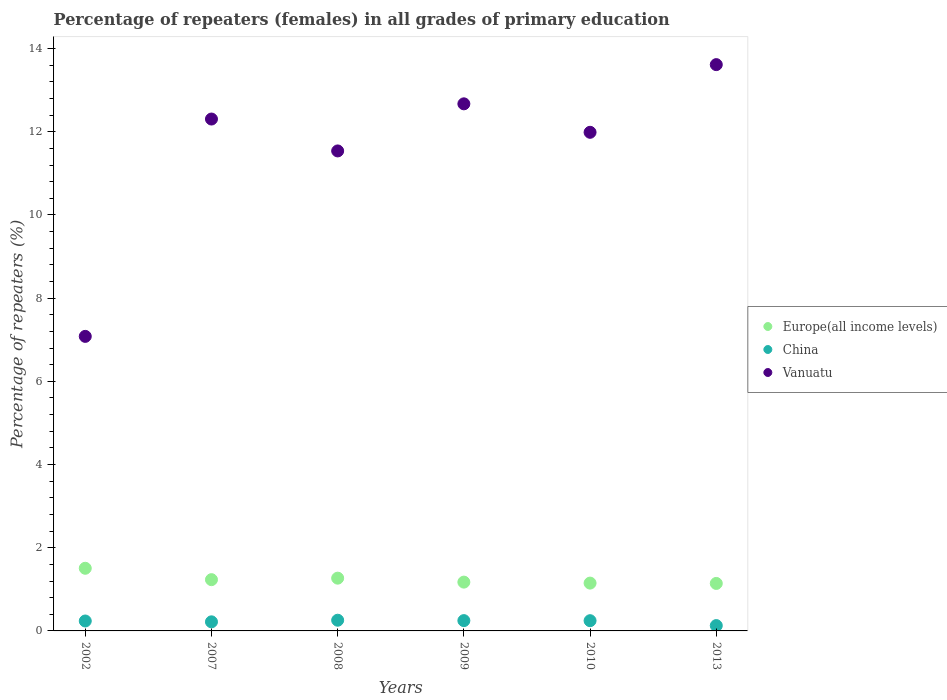How many different coloured dotlines are there?
Your response must be concise. 3. Is the number of dotlines equal to the number of legend labels?
Offer a terse response. Yes. What is the percentage of repeaters (females) in Europe(all income levels) in 2002?
Offer a very short reply. 1.51. Across all years, what is the maximum percentage of repeaters (females) in Vanuatu?
Offer a terse response. 13.61. Across all years, what is the minimum percentage of repeaters (females) in China?
Provide a succinct answer. 0.13. What is the total percentage of repeaters (females) in Europe(all income levels) in the graph?
Your response must be concise. 7.47. What is the difference between the percentage of repeaters (females) in China in 2002 and that in 2007?
Give a very brief answer. 0.02. What is the difference between the percentage of repeaters (females) in Vanuatu in 2009 and the percentage of repeaters (females) in China in 2010?
Offer a terse response. 12.42. What is the average percentage of repeaters (females) in Vanuatu per year?
Provide a succinct answer. 11.53. In the year 2009, what is the difference between the percentage of repeaters (females) in Europe(all income levels) and percentage of repeaters (females) in Vanuatu?
Your answer should be compact. -11.5. In how many years, is the percentage of repeaters (females) in Vanuatu greater than 10.4 %?
Provide a short and direct response. 5. What is the ratio of the percentage of repeaters (females) in China in 2002 to that in 2009?
Offer a terse response. 0.96. Is the difference between the percentage of repeaters (females) in Europe(all income levels) in 2008 and 2009 greater than the difference between the percentage of repeaters (females) in Vanuatu in 2008 and 2009?
Keep it short and to the point. Yes. What is the difference between the highest and the second highest percentage of repeaters (females) in Vanuatu?
Offer a very short reply. 0.94. What is the difference between the highest and the lowest percentage of repeaters (females) in Vanuatu?
Keep it short and to the point. 6.53. In how many years, is the percentage of repeaters (females) in Europe(all income levels) greater than the average percentage of repeaters (females) in Europe(all income levels) taken over all years?
Provide a short and direct response. 2. Is the percentage of repeaters (females) in China strictly greater than the percentage of repeaters (females) in Europe(all income levels) over the years?
Offer a terse response. No. What is the difference between two consecutive major ticks on the Y-axis?
Your response must be concise. 2. Are the values on the major ticks of Y-axis written in scientific E-notation?
Keep it short and to the point. No. Does the graph contain any zero values?
Your answer should be very brief. No. Does the graph contain grids?
Give a very brief answer. No. Where does the legend appear in the graph?
Provide a short and direct response. Center right. What is the title of the graph?
Your answer should be compact. Percentage of repeaters (females) in all grades of primary education. Does "Cyprus" appear as one of the legend labels in the graph?
Your response must be concise. No. What is the label or title of the X-axis?
Ensure brevity in your answer.  Years. What is the label or title of the Y-axis?
Your answer should be very brief. Percentage of repeaters (%). What is the Percentage of repeaters (%) in Europe(all income levels) in 2002?
Offer a very short reply. 1.51. What is the Percentage of repeaters (%) in China in 2002?
Your answer should be very brief. 0.24. What is the Percentage of repeaters (%) in Vanuatu in 2002?
Your answer should be compact. 7.08. What is the Percentage of repeaters (%) in Europe(all income levels) in 2007?
Your response must be concise. 1.23. What is the Percentage of repeaters (%) in China in 2007?
Provide a succinct answer. 0.22. What is the Percentage of repeaters (%) of Vanuatu in 2007?
Keep it short and to the point. 12.31. What is the Percentage of repeaters (%) in Europe(all income levels) in 2008?
Offer a very short reply. 1.27. What is the Percentage of repeaters (%) in China in 2008?
Offer a very short reply. 0.26. What is the Percentage of repeaters (%) in Vanuatu in 2008?
Give a very brief answer. 11.54. What is the Percentage of repeaters (%) of Europe(all income levels) in 2009?
Keep it short and to the point. 1.17. What is the Percentage of repeaters (%) in China in 2009?
Your answer should be very brief. 0.25. What is the Percentage of repeaters (%) in Vanuatu in 2009?
Your answer should be compact. 12.67. What is the Percentage of repeaters (%) of Europe(all income levels) in 2010?
Your answer should be compact. 1.15. What is the Percentage of repeaters (%) of China in 2010?
Ensure brevity in your answer.  0.25. What is the Percentage of repeaters (%) of Vanuatu in 2010?
Your answer should be very brief. 11.99. What is the Percentage of repeaters (%) of Europe(all income levels) in 2013?
Offer a terse response. 1.14. What is the Percentage of repeaters (%) of China in 2013?
Your answer should be compact. 0.13. What is the Percentage of repeaters (%) in Vanuatu in 2013?
Give a very brief answer. 13.61. Across all years, what is the maximum Percentage of repeaters (%) of Europe(all income levels)?
Make the answer very short. 1.51. Across all years, what is the maximum Percentage of repeaters (%) in China?
Provide a short and direct response. 0.26. Across all years, what is the maximum Percentage of repeaters (%) in Vanuatu?
Your answer should be compact. 13.61. Across all years, what is the minimum Percentage of repeaters (%) of Europe(all income levels)?
Make the answer very short. 1.14. Across all years, what is the minimum Percentage of repeaters (%) in China?
Provide a short and direct response. 0.13. Across all years, what is the minimum Percentage of repeaters (%) in Vanuatu?
Offer a terse response. 7.08. What is the total Percentage of repeaters (%) in Europe(all income levels) in the graph?
Your answer should be compact. 7.47. What is the total Percentage of repeaters (%) in China in the graph?
Make the answer very short. 1.34. What is the total Percentage of repeaters (%) of Vanuatu in the graph?
Your answer should be compact. 69.19. What is the difference between the Percentage of repeaters (%) of Europe(all income levels) in 2002 and that in 2007?
Offer a terse response. 0.27. What is the difference between the Percentage of repeaters (%) in Vanuatu in 2002 and that in 2007?
Provide a succinct answer. -5.22. What is the difference between the Percentage of repeaters (%) of Europe(all income levels) in 2002 and that in 2008?
Your answer should be very brief. 0.24. What is the difference between the Percentage of repeaters (%) of China in 2002 and that in 2008?
Your response must be concise. -0.02. What is the difference between the Percentage of repeaters (%) in Vanuatu in 2002 and that in 2008?
Ensure brevity in your answer.  -4.46. What is the difference between the Percentage of repeaters (%) in Europe(all income levels) in 2002 and that in 2009?
Provide a short and direct response. 0.33. What is the difference between the Percentage of repeaters (%) in China in 2002 and that in 2009?
Offer a terse response. -0.01. What is the difference between the Percentage of repeaters (%) in Vanuatu in 2002 and that in 2009?
Ensure brevity in your answer.  -5.59. What is the difference between the Percentage of repeaters (%) of Europe(all income levels) in 2002 and that in 2010?
Offer a very short reply. 0.36. What is the difference between the Percentage of repeaters (%) in China in 2002 and that in 2010?
Your answer should be compact. -0.01. What is the difference between the Percentage of repeaters (%) of Vanuatu in 2002 and that in 2010?
Make the answer very short. -4.91. What is the difference between the Percentage of repeaters (%) of Europe(all income levels) in 2002 and that in 2013?
Keep it short and to the point. 0.36. What is the difference between the Percentage of repeaters (%) in China in 2002 and that in 2013?
Ensure brevity in your answer.  0.11. What is the difference between the Percentage of repeaters (%) in Vanuatu in 2002 and that in 2013?
Give a very brief answer. -6.53. What is the difference between the Percentage of repeaters (%) in Europe(all income levels) in 2007 and that in 2008?
Ensure brevity in your answer.  -0.04. What is the difference between the Percentage of repeaters (%) in China in 2007 and that in 2008?
Your response must be concise. -0.04. What is the difference between the Percentage of repeaters (%) of Vanuatu in 2007 and that in 2008?
Provide a short and direct response. 0.77. What is the difference between the Percentage of repeaters (%) in Europe(all income levels) in 2007 and that in 2009?
Give a very brief answer. 0.06. What is the difference between the Percentage of repeaters (%) of China in 2007 and that in 2009?
Ensure brevity in your answer.  -0.03. What is the difference between the Percentage of repeaters (%) in Vanuatu in 2007 and that in 2009?
Offer a very short reply. -0.37. What is the difference between the Percentage of repeaters (%) of Europe(all income levels) in 2007 and that in 2010?
Your answer should be very brief. 0.08. What is the difference between the Percentage of repeaters (%) in China in 2007 and that in 2010?
Keep it short and to the point. -0.03. What is the difference between the Percentage of repeaters (%) in Vanuatu in 2007 and that in 2010?
Ensure brevity in your answer.  0.32. What is the difference between the Percentage of repeaters (%) of Europe(all income levels) in 2007 and that in 2013?
Your answer should be compact. 0.09. What is the difference between the Percentage of repeaters (%) of China in 2007 and that in 2013?
Keep it short and to the point. 0.09. What is the difference between the Percentage of repeaters (%) of Vanuatu in 2007 and that in 2013?
Offer a terse response. -1.31. What is the difference between the Percentage of repeaters (%) of Europe(all income levels) in 2008 and that in 2009?
Your answer should be compact. 0.1. What is the difference between the Percentage of repeaters (%) in China in 2008 and that in 2009?
Ensure brevity in your answer.  0.01. What is the difference between the Percentage of repeaters (%) of Vanuatu in 2008 and that in 2009?
Make the answer very short. -1.13. What is the difference between the Percentage of repeaters (%) of Europe(all income levels) in 2008 and that in 2010?
Keep it short and to the point. 0.12. What is the difference between the Percentage of repeaters (%) of China in 2008 and that in 2010?
Ensure brevity in your answer.  0.01. What is the difference between the Percentage of repeaters (%) in Vanuatu in 2008 and that in 2010?
Provide a short and direct response. -0.45. What is the difference between the Percentage of repeaters (%) of Europe(all income levels) in 2008 and that in 2013?
Give a very brief answer. 0.13. What is the difference between the Percentage of repeaters (%) in China in 2008 and that in 2013?
Ensure brevity in your answer.  0.13. What is the difference between the Percentage of repeaters (%) of Vanuatu in 2008 and that in 2013?
Keep it short and to the point. -2.07. What is the difference between the Percentage of repeaters (%) of Europe(all income levels) in 2009 and that in 2010?
Provide a succinct answer. 0.02. What is the difference between the Percentage of repeaters (%) of China in 2009 and that in 2010?
Give a very brief answer. 0. What is the difference between the Percentage of repeaters (%) in Vanuatu in 2009 and that in 2010?
Your answer should be compact. 0.68. What is the difference between the Percentage of repeaters (%) in Europe(all income levels) in 2009 and that in 2013?
Offer a terse response. 0.03. What is the difference between the Percentage of repeaters (%) of China in 2009 and that in 2013?
Offer a very short reply. 0.12. What is the difference between the Percentage of repeaters (%) in Vanuatu in 2009 and that in 2013?
Provide a short and direct response. -0.94. What is the difference between the Percentage of repeaters (%) of Europe(all income levels) in 2010 and that in 2013?
Provide a succinct answer. 0.01. What is the difference between the Percentage of repeaters (%) in China in 2010 and that in 2013?
Give a very brief answer. 0.12. What is the difference between the Percentage of repeaters (%) of Vanuatu in 2010 and that in 2013?
Give a very brief answer. -1.63. What is the difference between the Percentage of repeaters (%) of Europe(all income levels) in 2002 and the Percentage of repeaters (%) of China in 2007?
Your answer should be compact. 1.29. What is the difference between the Percentage of repeaters (%) in Europe(all income levels) in 2002 and the Percentage of repeaters (%) in Vanuatu in 2007?
Provide a succinct answer. -10.8. What is the difference between the Percentage of repeaters (%) of China in 2002 and the Percentage of repeaters (%) of Vanuatu in 2007?
Ensure brevity in your answer.  -12.07. What is the difference between the Percentage of repeaters (%) in Europe(all income levels) in 2002 and the Percentage of repeaters (%) in China in 2008?
Your response must be concise. 1.25. What is the difference between the Percentage of repeaters (%) in Europe(all income levels) in 2002 and the Percentage of repeaters (%) in Vanuatu in 2008?
Offer a very short reply. -10.03. What is the difference between the Percentage of repeaters (%) of China in 2002 and the Percentage of repeaters (%) of Vanuatu in 2008?
Offer a very short reply. -11.3. What is the difference between the Percentage of repeaters (%) of Europe(all income levels) in 2002 and the Percentage of repeaters (%) of China in 2009?
Offer a very short reply. 1.26. What is the difference between the Percentage of repeaters (%) of Europe(all income levels) in 2002 and the Percentage of repeaters (%) of Vanuatu in 2009?
Offer a terse response. -11.16. What is the difference between the Percentage of repeaters (%) of China in 2002 and the Percentage of repeaters (%) of Vanuatu in 2009?
Your answer should be compact. -12.43. What is the difference between the Percentage of repeaters (%) in Europe(all income levels) in 2002 and the Percentage of repeaters (%) in China in 2010?
Offer a very short reply. 1.26. What is the difference between the Percentage of repeaters (%) of Europe(all income levels) in 2002 and the Percentage of repeaters (%) of Vanuatu in 2010?
Give a very brief answer. -10.48. What is the difference between the Percentage of repeaters (%) in China in 2002 and the Percentage of repeaters (%) in Vanuatu in 2010?
Your response must be concise. -11.75. What is the difference between the Percentage of repeaters (%) in Europe(all income levels) in 2002 and the Percentage of repeaters (%) in China in 2013?
Ensure brevity in your answer.  1.38. What is the difference between the Percentage of repeaters (%) in Europe(all income levels) in 2002 and the Percentage of repeaters (%) in Vanuatu in 2013?
Give a very brief answer. -12.11. What is the difference between the Percentage of repeaters (%) in China in 2002 and the Percentage of repeaters (%) in Vanuatu in 2013?
Your answer should be very brief. -13.37. What is the difference between the Percentage of repeaters (%) in Europe(all income levels) in 2007 and the Percentage of repeaters (%) in China in 2008?
Your answer should be very brief. 0.98. What is the difference between the Percentage of repeaters (%) of Europe(all income levels) in 2007 and the Percentage of repeaters (%) of Vanuatu in 2008?
Make the answer very short. -10.31. What is the difference between the Percentage of repeaters (%) of China in 2007 and the Percentage of repeaters (%) of Vanuatu in 2008?
Make the answer very short. -11.32. What is the difference between the Percentage of repeaters (%) of Europe(all income levels) in 2007 and the Percentage of repeaters (%) of China in 2009?
Offer a very short reply. 0.98. What is the difference between the Percentage of repeaters (%) of Europe(all income levels) in 2007 and the Percentage of repeaters (%) of Vanuatu in 2009?
Ensure brevity in your answer.  -11.44. What is the difference between the Percentage of repeaters (%) of China in 2007 and the Percentage of repeaters (%) of Vanuatu in 2009?
Your answer should be very brief. -12.45. What is the difference between the Percentage of repeaters (%) of Europe(all income levels) in 2007 and the Percentage of repeaters (%) of China in 2010?
Your answer should be very brief. 0.99. What is the difference between the Percentage of repeaters (%) in Europe(all income levels) in 2007 and the Percentage of repeaters (%) in Vanuatu in 2010?
Provide a succinct answer. -10.75. What is the difference between the Percentage of repeaters (%) in China in 2007 and the Percentage of repeaters (%) in Vanuatu in 2010?
Your answer should be very brief. -11.77. What is the difference between the Percentage of repeaters (%) in Europe(all income levels) in 2007 and the Percentage of repeaters (%) in China in 2013?
Provide a short and direct response. 1.1. What is the difference between the Percentage of repeaters (%) of Europe(all income levels) in 2007 and the Percentage of repeaters (%) of Vanuatu in 2013?
Your answer should be compact. -12.38. What is the difference between the Percentage of repeaters (%) in China in 2007 and the Percentage of repeaters (%) in Vanuatu in 2013?
Give a very brief answer. -13.39. What is the difference between the Percentage of repeaters (%) in Europe(all income levels) in 2008 and the Percentage of repeaters (%) in China in 2009?
Ensure brevity in your answer.  1.02. What is the difference between the Percentage of repeaters (%) in Europe(all income levels) in 2008 and the Percentage of repeaters (%) in Vanuatu in 2009?
Offer a very short reply. -11.4. What is the difference between the Percentage of repeaters (%) of China in 2008 and the Percentage of repeaters (%) of Vanuatu in 2009?
Your answer should be very brief. -12.41. What is the difference between the Percentage of repeaters (%) in Europe(all income levels) in 2008 and the Percentage of repeaters (%) in China in 2010?
Provide a short and direct response. 1.02. What is the difference between the Percentage of repeaters (%) of Europe(all income levels) in 2008 and the Percentage of repeaters (%) of Vanuatu in 2010?
Your answer should be very brief. -10.72. What is the difference between the Percentage of repeaters (%) in China in 2008 and the Percentage of repeaters (%) in Vanuatu in 2010?
Give a very brief answer. -11.73. What is the difference between the Percentage of repeaters (%) in Europe(all income levels) in 2008 and the Percentage of repeaters (%) in China in 2013?
Give a very brief answer. 1.14. What is the difference between the Percentage of repeaters (%) of Europe(all income levels) in 2008 and the Percentage of repeaters (%) of Vanuatu in 2013?
Make the answer very short. -12.34. What is the difference between the Percentage of repeaters (%) of China in 2008 and the Percentage of repeaters (%) of Vanuatu in 2013?
Give a very brief answer. -13.36. What is the difference between the Percentage of repeaters (%) of Europe(all income levels) in 2009 and the Percentage of repeaters (%) of China in 2010?
Offer a terse response. 0.93. What is the difference between the Percentage of repeaters (%) in Europe(all income levels) in 2009 and the Percentage of repeaters (%) in Vanuatu in 2010?
Give a very brief answer. -10.81. What is the difference between the Percentage of repeaters (%) of China in 2009 and the Percentage of repeaters (%) of Vanuatu in 2010?
Give a very brief answer. -11.74. What is the difference between the Percentage of repeaters (%) in Europe(all income levels) in 2009 and the Percentage of repeaters (%) in China in 2013?
Keep it short and to the point. 1.05. What is the difference between the Percentage of repeaters (%) of Europe(all income levels) in 2009 and the Percentage of repeaters (%) of Vanuatu in 2013?
Your answer should be compact. -12.44. What is the difference between the Percentage of repeaters (%) of China in 2009 and the Percentage of repeaters (%) of Vanuatu in 2013?
Provide a succinct answer. -13.37. What is the difference between the Percentage of repeaters (%) of Europe(all income levels) in 2010 and the Percentage of repeaters (%) of China in 2013?
Give a very brief answer. 1.02. What is the difference between the Percentage of repeaters (%) in Europe(all income levels) in 2010 and the Percentage of repeaters (%) in Vanuatu in 2013?
Offer a very short reply. -12.46. What is the difference between the Percentage of repeaters (%) of China in 2010 and the Percentage of repeaters (%) of Vanuatu in 2013?
Offer a terse response. -13.37. What is the average Percentage of repeaters (%) in Europe(all income levels) per year?
Ensure brevity in your answer.  1.25. What is the average Percentage of repeaters (%) of China per year?
Offer a terse response. 0.22. What is the average Percentage of repeaters (%) in Vanuatu per year?
Your answer should be compact. 11.53. In the year 2002, what is the difference between the Percentage of repeaters (%) in Europe(all income levels) and Percentage of repeaters (%) in China?
Make the answer very short. 1.27. In the year 2002, what is the difference between the Percentage of repeaters (%) of Europe(all income levels) and Percentage of repeaters (%) of Vanuatu?
Your answer should be very brief. -5.57. In the year 2002, what is the difference between the Percentage of repeaters (%) in China and Percentage of repeaters (%) in Vanuatu?
Your answer should be compact. -6.84. In the year 2007, what is the difference between the Percentage of repeaters (%) of Europe(all income levels) and Percentage of repeaters (%) of China?
Offer a terse response. 1.01. In the year 2007, what is the difference between the Percentage of repeaters (%) in Europe(all income levels) and Percentage of repeaters (%) in Vanuatu?
Your response must be concise. -11.07. In the year 2007, what is the difference between the Percentage of repeaters (%) of China and Percentage of repeaters (%) of Vanuatu?
Your response must be concise. -12.09. In the year 2008, what is the difference between the Percentage of repeaters (%) in Europe(all income levels) and Percentage of repeaters (%) in China?
Your response must be concise. 1.01. In the year 2008, what is the difference between the Percentage of repeaters (%) in Europe(all income levels) and Percentage of repeaters (%) in Vanuatu?
Your response must be concise. -10.27. In the year 2008, what is the difference between the Percentage of repeaters (%) in China and Percentage of repeaters (%) in Vanuatu?
Provide a short and direct response. -11.28. In the year 2009, what is the difference between the Percentage of repeaters (%) of Europe(all income levels) and Percentage of repeaters (%) of China?
Your response must be concise. 0.93. In the year 2009, what is the difference between the Percentage of repeaters (%) in Europe(all income levels) and Percentage of repeaters (%) in Vanuatu?
Provide a short and direct response. -11.5. In the year 2009, what is the difference between the Percentage of repeaters (%) in China and Percentage of repeaters (%) in Vanuatu?
Your answer should be compact. -12.42. In the year 2010, what is the difference between the Percentage of repeaters (%) of Europe(all income levels) and Percentage of repeaters (%) of China?
Ensure brevity in your answer.  0.9. In the year 2010, what is the difference between the Percentage of repeaters (%) of Europe(all income levels) and Percentage of repeaters (%) of Vanuatu?
Provide a short and direct response. -10.84. In the year 2010, what is the difference between the Percentage of repeaters (%) of China and Percentage of repeaters (%) of Vanuatu?
Provide a short and direct response. -11.74. In the year 2013, what is the difference between the Percentage of repeaters (%) in Europe(all income levels) and Percentage of repeaters (%) in China?
Keep it short and to the point. 1.01. In the year 2013, what is the difference between the Percentage of repeaters (%) of Europe(all income levels) and Percentage of repeaters (%) of Vanuatu?
Your answer should be very brief. -12.47. In the year 2013, what is the difference between the Percentage of repeaters (%) in China and Percentage of repeaters (%) in Vanuatu?
Your answer should be compact. -13.49. What is the ratio of the Percentage of repeaters (%) in Europe(all income levels) in 2002 to that in 2007?
Give a very brief answer. 1.22. What is the ratio of the Percentage of repeaters (%) in China in 2002 to that in 2007?
Your answer should be very brief. 1.09. What is the ratio of the Percentage of repeaters (%) in Vanuatu in 2002 to that in 2007?
Provide a short and direct response. 0.58. What is the ratio of the Percentage of repeaters (%) of Europe(all income levels) in 2002 to that in 2008?
Ensure brevity in your answer.  1.19. What is the ratio of the Percentage of repeaters (%) in China in 2002 to that in 2008?
Your response must be concise. 0.93. What is the ratio of the Percentage of repeaters (%) of Vanuatu in 2002 to that in 2008?
Offer a very short reply. 0.61. What is the ratio of the Percentage of repeaters (%) in Europe(all income levels) in 2002 to that in 2009?
Offer a terse response. 1.28. What is the ratio of the Percentage of repeaters (%) of China in 2002 to that in 2009?
Offer a terse response. 0.96. What is the ratio of the Percentage of repeaters (%) in Vanuatu in 2002 to that in 2009?
Make the answer very short. 0.56. What is the ratio of the Percentage of repeaters (%) of Europe(all income levels) in 2002 to that in 2010?
Provide a short and direct response. 1.31. What is the ratio of the Percentage of repeaters (%) in China in 2002 to that in 2010?
Offer a very short reply. 0.97. What is the ratio of the Percentage of repeaters (%) of Vanuatu in 2002 to that in 2010?
Your answer should be compact. 0.59. What is the ratio of the Percentage of repeaters (%) of Europe(all income levels) in 2002 to that in 2013?
Make the answer very short. 1.32. What is the ratio of the Percentage of repeaters (%) in China in 2002 to that in 2013?
Your answer should be very brief. 1.86. What is the ratio of the Percentage of repeaters (%) in Vanuatu in 2002 to that in 2013?
Ensure brevity in your answer.  0.52. What is the ratio of the Percentage of repeaters (%) in Europe(all income levels) in 2007 to that in 2008?
Offer a very short reply. 0.97. What is the ratio of the Percentage of repeaters (%) in China in 2007 to that in 2008?
Your answer should be very brief. 0.85. What is the ratio of the Percentage of repeaters (%) in Vanuatu in 2007 to that in 2008?
Provide a succinct answer. 1.07. What is the ratio of the Percentage of repeaters (%) in Europe(all income levels) in 2007 to that in 2009?
Make the answer very short. 1.05. What is the ratio of the Percentage of repeaters (%) in China in 2007 to that in 2009?
Your response must be concise. 0.88. What is the ratio of the Percentage of repeaters (%) of Vanuatu in 2007 to that in 2009?
Provide a succinct answer. 0.97. What is the ratio of the Percentage of repeaters (%) in Europe(all income levels) in 2007 to that in 2010?
Your response must be concise. 1.07. What is the ratio of the Percentage of repeaters (%) of China in 2007 to that in 2010?
Offer a terse response. 0.89. What is the ratio of the Percentage of repeaters (%) of Vanuatu in 2007 to that in 2010?
Ensure brevity in your answer.  1.03. What is the ratio of the Percentage of repeaters (%) of Europe(all income levels) in 2007 to that in 2013?
Provide a succinct answer. 1.08. What is the ratio of the Percentage of repeaters (%) of China in 2007 to that in 2013?
Offer a very short reply. 1.71. What is the ratio of the Percentage of repeaters (%) of Vanuatu in 2007 to that in 2013?
Ensure brevity in your answer.  0.9. What is the ratio of the Percentage of repeaters (%) of Europe(all income levels) in 2008 to that in 2009?
Provide a succinct answer. 1.08. What is the ratio of the Percentage of repeaters (%) in China in 2008 to that in 2009?
Provide a short and direct response. 1.04. What is the ratio of the Percentage of repeaters (%) of Vanuatu in 2008 to that in 2009?
Offer a very short reply. 0.91. What is the ratio of the Percentage of repeaters (%) in Europe(all income levels) in 2008 to that in 2010?
Provide a succinct answer. 1.1. What is the ratio of the Percentage of repeaters (%) in China in 2008 to that in 2010?
Make the answer very short. 1.05. What is the ratio of the Percentage of repeaters (%) in Vanuatu in 2008 to that in 2010?
Your answer should be compact. 0.96. What is the ratio of the Percentage of repeaters (%) in Europe(all income levels) in 2008 to that in 2013?
Provide a succinct answer. 1.11. What is the ratio of the Percentage of repeaters (%) in China in 2008 to that in 2013?
Keep it short and to the point. 2.01. What is the ratio of the Percentage of repeaters (%) of Vanuatu in 2008 to that in 2013?
Keep it short and to the point. 0.85. What is the ratio of the Percentage of repeaters (%) of Europe(all income levels) in 2009 to that in 2010?
Give a very brief answer. 1.02. What is the ratio of the Percentage of repeaters (%) of Vanuatu in 2009 to that in 2010?
Offer a very short reply. 1.06. What is the ratio of the Percentage of repeaters (%) of Europe(all income levels) in 2009 to that in 2013?
Provide a short and direct response. 1.03. What is the ratio of the Percentage of repeaters (%) of China in 2009 to that in 2013?
Offer a very short reply. 1.93. What is the ratio of the Percentage of repeaters (%) of Vanuatu in 2009 to that in 2013?
Your response must be concise. 0.93. What is the ratio of the Percentage of repeaters (%) in Europe(all income levels) in 2010 to that in 2013?
Offer a terse response. 1.01. What is the ratio of the Percentage of repeaters (%) of China in 2010 to that in 2013?
Offer a very short reply. 1.92. What is the ratio of the Percentage of repeaters (%) of Vanuatu in 2010 to that in 2013?
Your response must be concise. 0.88. What is the difference between the highest and the second highest Percentage of repeaters (%) in Europe(all income levels)?
Keep it short and to the point. 0.24. What is the difference between the highest and the second highest Percentage of repeaters (%) of China?
Provide a succinct answer. 0.01. What is the difference between the highest and the second highest Percentage of repeaters (%) in Vanuatu?
Offer a terse response. 0.94. What is the difference between the highest and the lowest Percentage of repeaters (%) of Europe(all income levels)?
Your answer should be very brief. 0.36. What is the difference between the highest and the lowest Percentage of repeaters (%) of China?
Ensure brevity in your answer.  0.13. What is the difference between the highest and the lowest Percentage of repeaters (%) of Vanuatu?
Keep it short and to the point. 6.53. 